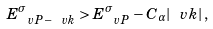Convert formula to latex. <formula><loc_0><loc_0><loc_500><loc_500>E ^ { \sigma } _ { \ v P - \ v k } > E ^ { \sigma } _ { \ v P } - C _ { \alpha } | \ v k | \, ,</formula> 